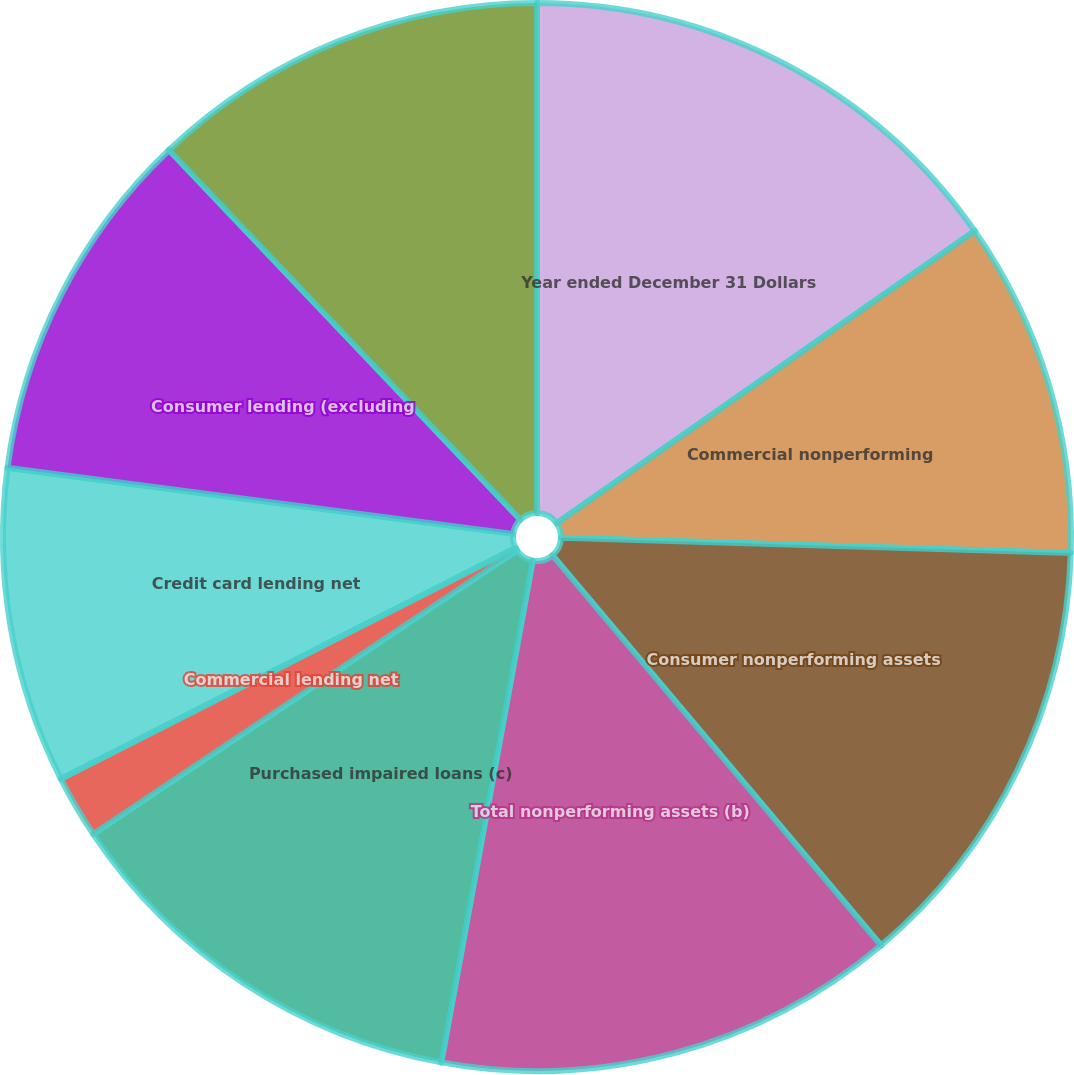<chart> <loc_0><loc_0><loc_500><loc_500><pie_chart><fcel>Year ended December 31 Dollars<fcel>Commercial nonperforming<fcel>Consumer nonperforming assets<fcel>Total nonperforming assets (b)<fcel>Purchased impaired loans (c)<fcel>Commercial lending net<fcel>Credit card lending net<fcel>Consumer lending (excluding<fcel>Total net charge-offs<nl><fcel>15.29%<fcel>10.19%<fcel>13.38%<fcel>14.01%<fcel>12.74%<fcel>1.91%<fcel>9.55%<fcel>10.83%<fcel>12.1%<nl></chart> 